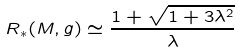Convert formula to latex. <formula><loc_0><loc_0><loc_500><loc_500>R _ { * } ( M , g ) \simeq \frac { 1 + \sqrt { 1 + 3 \lambda ^ { 2 } } } { \lambda }</formula> 